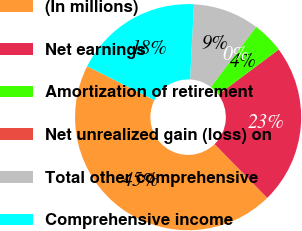<chart> <loc_0><loc_0><loc_500><loc_500><pie_chart><fcel>(In millions)<fcel>Net earnings<fcel>Amortization of retirement<fcel>Net unrealized gain (loss) on<fcel>Total other comprehensive<fcel>Comprehensive income<nl><fcel>44.78%<fcel>22.87%<fcel>4.5%<fcel>0.02%<fcel>9.44%<fcel>18.39%<nl></chart> 